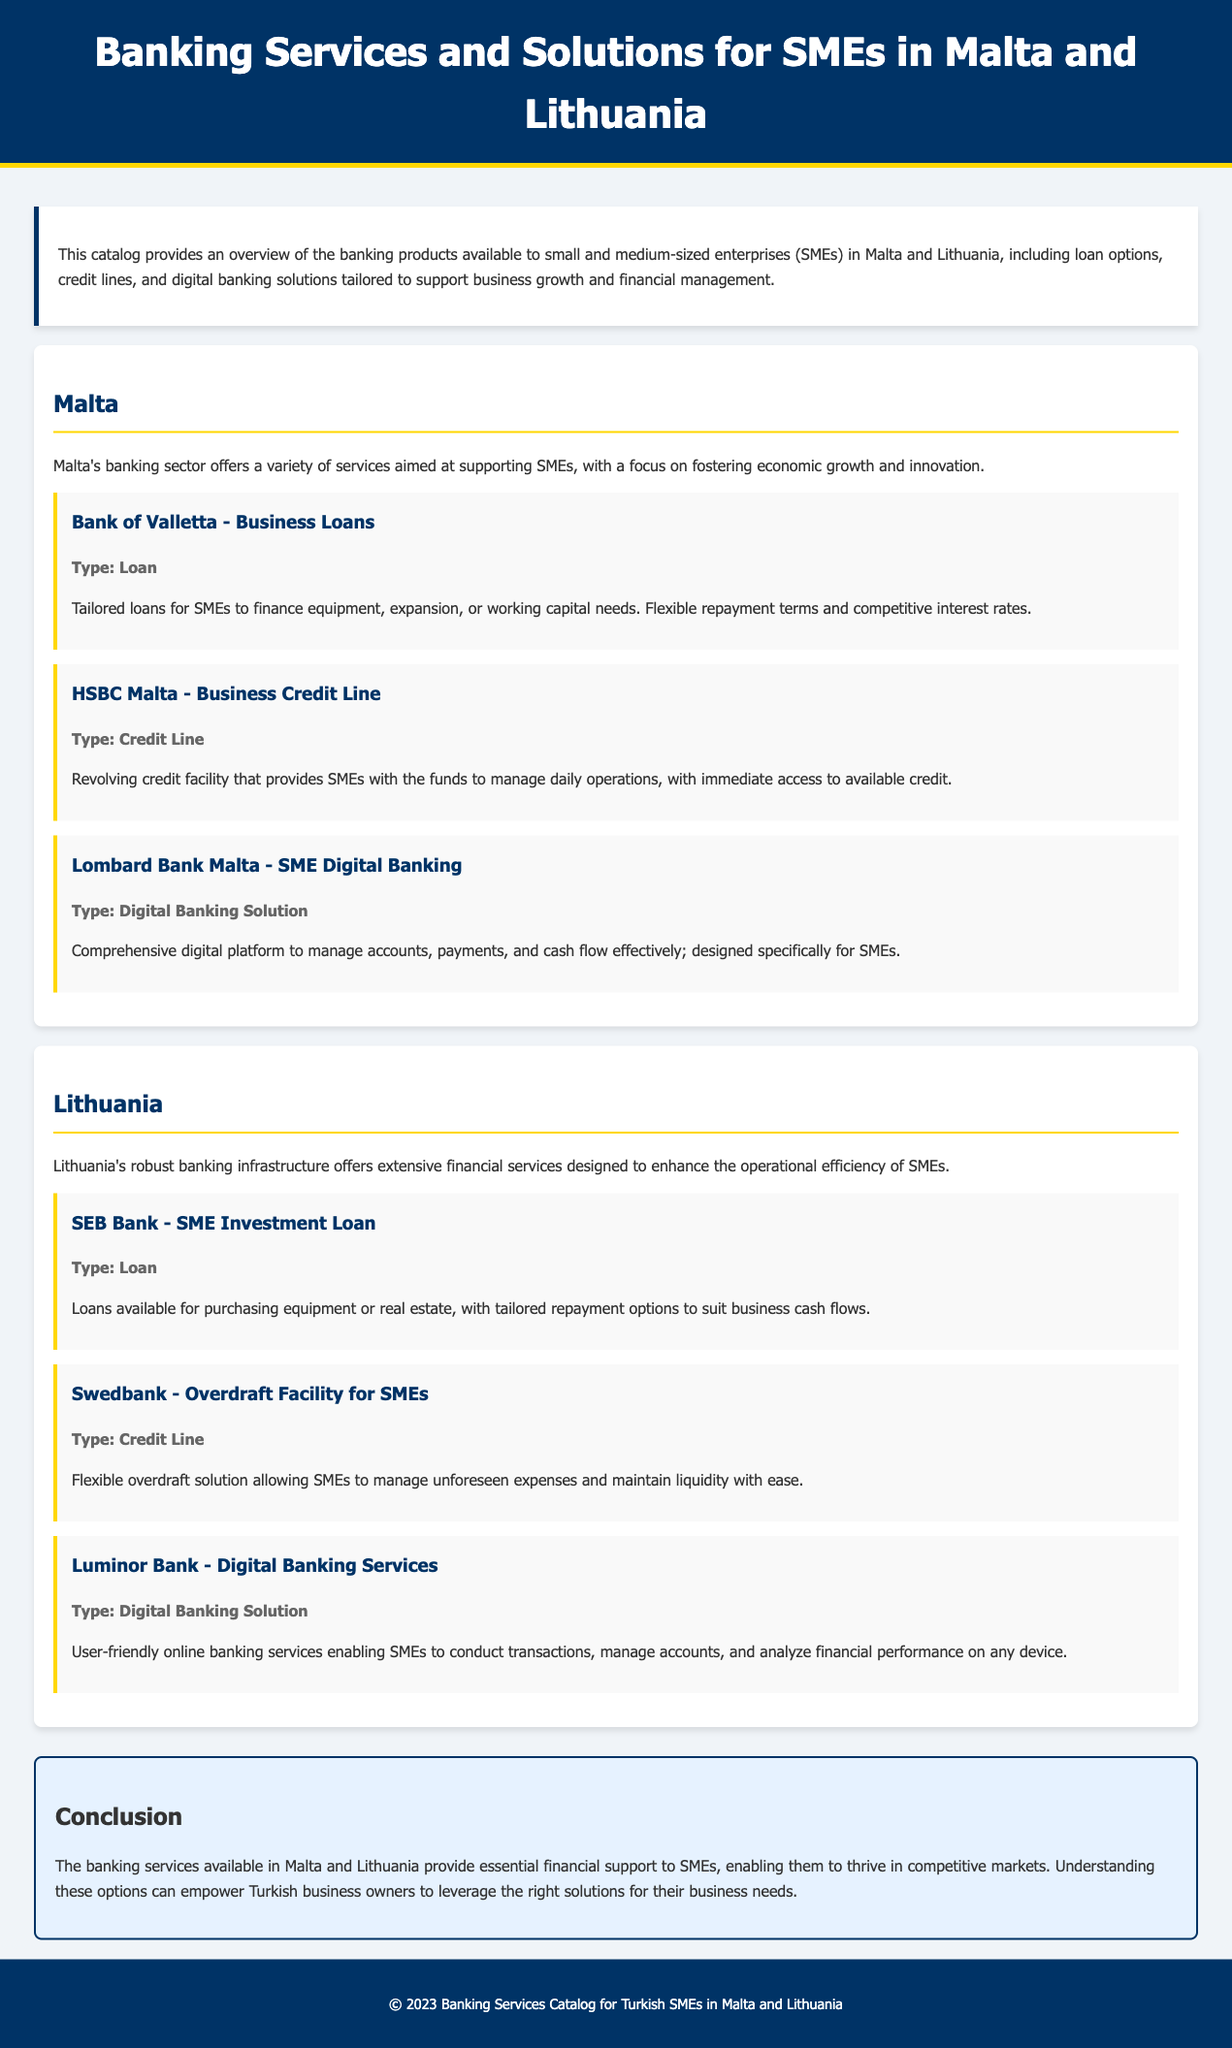What is the title of the catalog? The title of the catalog is presented in the header of the document.
Answer: Banking Services and Solutions for SMEs in Malta and Lithuania What does SEB Bank offer for SMEs? SEB Bank provides a specific financial product targeted towards SMEs, mentioned in the Lithuania section.
Answer: SME Investment Loan What type of product does HSBC Malta provide? The document specifies the type of financial service offered by HSBC Malta.
Answer: Credit Line What type of financial solution is provided by Lombard Bank Malta? The document describes the offering from Lombard Bank Malta in detail regarding its nature.
Answer: Digital Banking Solution What are the primary regions covered in the catalog? The catalog focuses on two specific geographical areas highlighted in the introduction.
Answer: Malta and Lithuania What is the repayment option feature of the SEB Bank's loans? The document mentions characteristics related to repayment options for SEB Bank's product.
Answer: Tailored repayment options Which bank offers an overdraft facility for SMEs in Lithuania? The catalog mentions a specific bank associated with an overdraft service for SMEs.
Answer: Swedbank How many banks are featured in the Malta section? The document lists multiple banks operating in Malta’s SME sector.
Answer: Three 